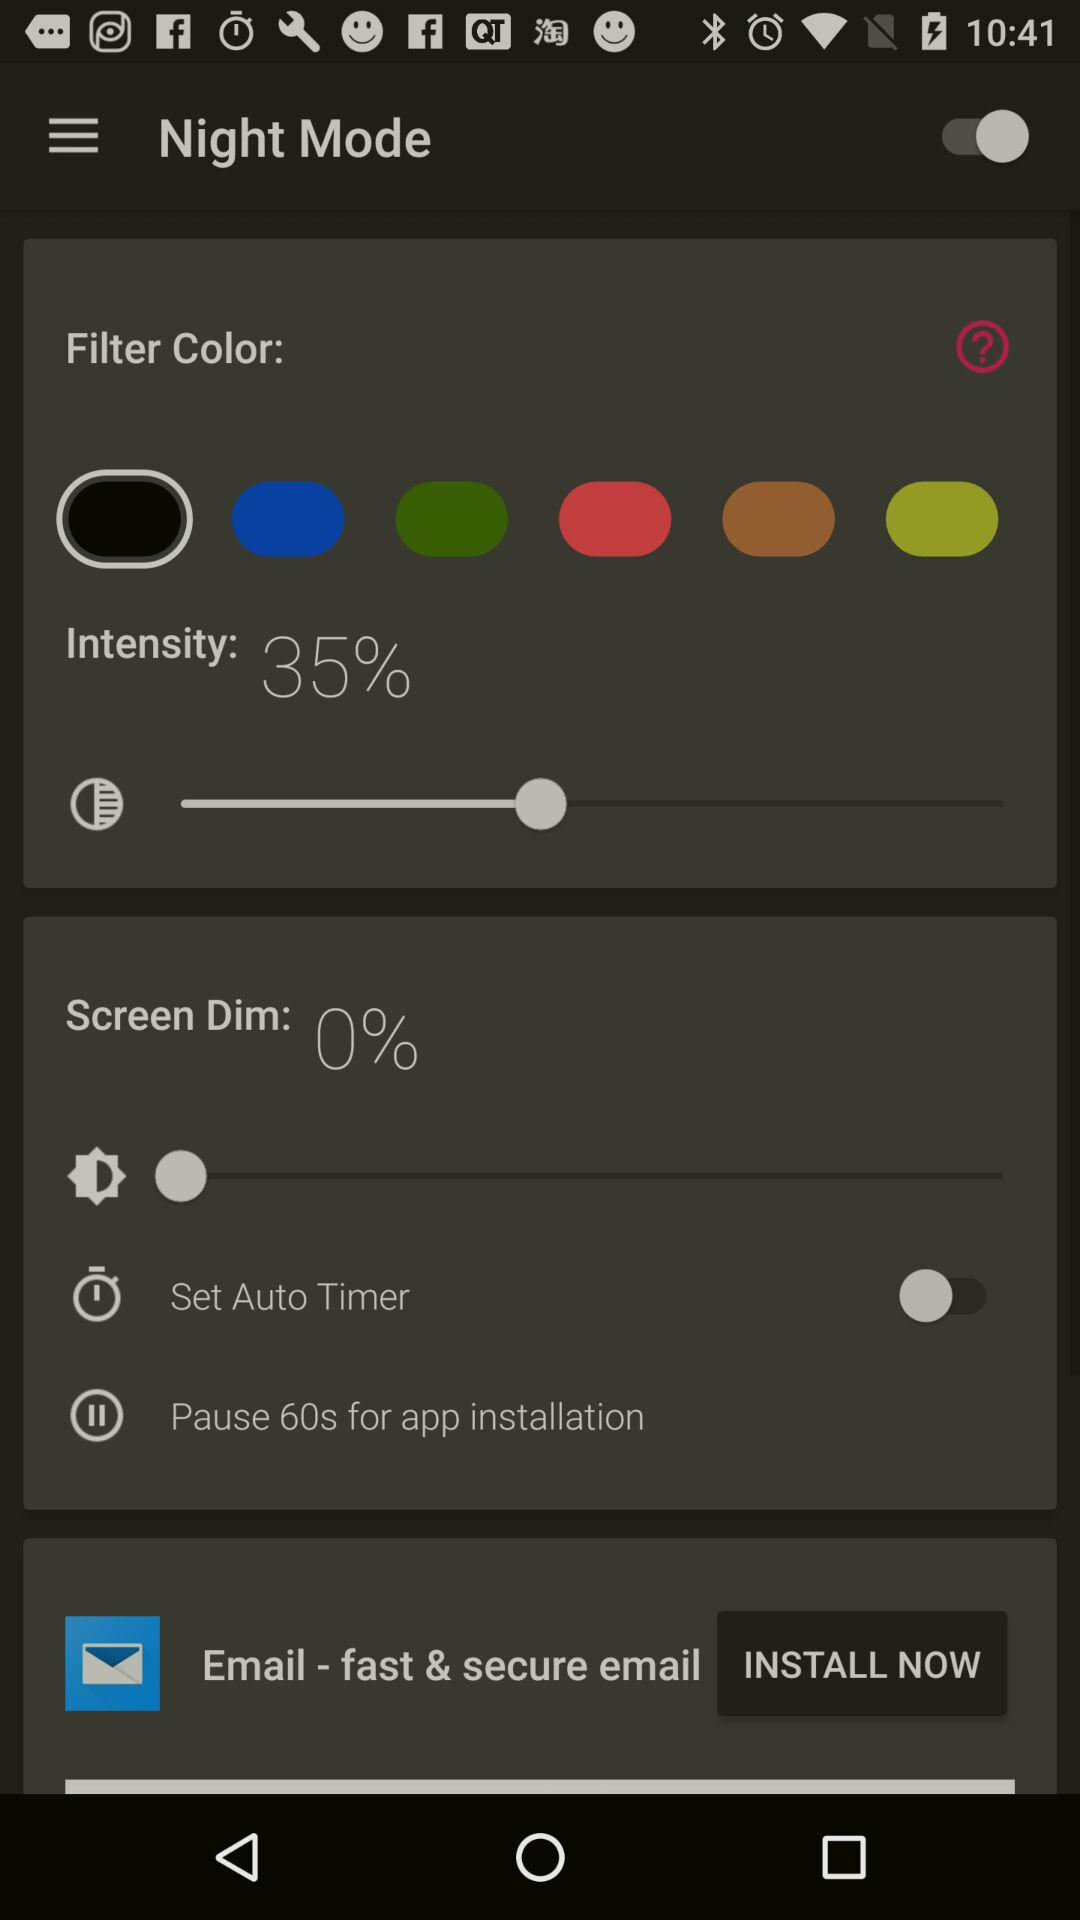What is the status of "Night Mode"? The status of "Night Mode" is "on". 